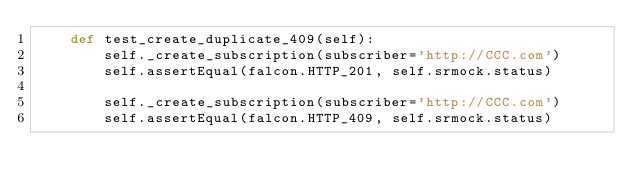Convert code to text. <code><loc_0><loc_0><loc_500><loc_500><_Python_>    def test_create_duplicate_409(self):
        self._create_subscription(subscriber='http://CCC.com')
        self.assertEqual(falcon.HTTP_201, self.srmock.status)

        self._create_subscription(subscriber='http://CCC.com')
        self.assertEqual(falcon.HTTP_409, self.srmock.status)
</code> 